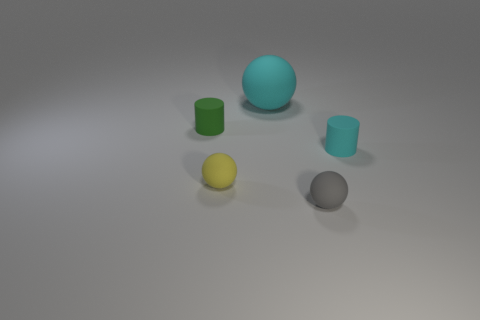Subtract all big cyan rubber spheres. How many spheres are left? 2 Subtract all brown spheres. Subtract all green cubes. How many spheres are left? 3 Add 5 small yellow shiny cylinders. How many objects exist? 10 Subtract all cylinders. How many objects are left? 3 Add 4 tiny green things. How many tiny green things are left? 5 Add 5 tiny gray rubber spheres. How many tiny gray rubber spheres exist? 6 Subtract 0 red cubes. How many objects are left? 5 Subtract all red matte cubes. Subtract all cyan objects. How many objects are left? 3 